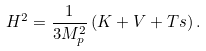<formula> <loc_0><loc_0><loc_500><loc_500>H ^ { 2 } = \frac { 1 } { 3 M _ { p } ^ { 2 } } \left ( K + V + T s \right ) .</formula> 